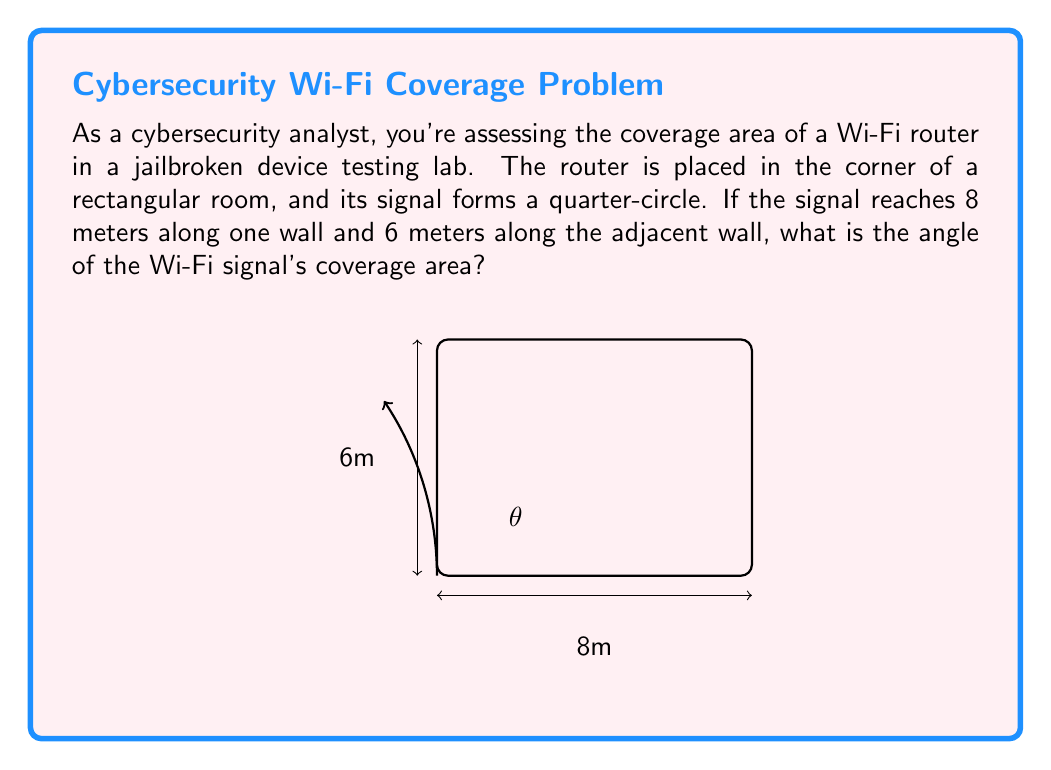Help me with this question. To solve this problem, we'll use trigonometry in a right triangle. Let's break it down step-by-step:

1) The Wi-Fi signal forms a quarter-circle, which is part of a right triangle. The two sides of this triangle are 8m and 6m.

2) We need to find the angle $\theta$ at the corner where the router is placed.

3) In a right triangle, we can use the arctangent function to find an angle when we know the opposite and adjacent sides.

4) In this case:
   - The opposite side is 6m
   - The adjacent side is 8m

5) The formula to use is:

   $$\theta = \arctan(\frac{\text{opposite}}{\text{adjacent}})$$

6) Plugging in our values:

   $$\theta = \arctan(\frac{6}{8})$$

7) Simplifying inside the parentheses:

   $$\theta = \arctan(0.75)$$

8) Using a calculator or computer to evaluate this:

   $$\theta \approx 36.87^\circ$$

9) Round to two decimal places for the final answer.

This angle represents the coverage area of the Wi-Fi signal in the corner of the room.
Answer: $36.87^\circ$ 